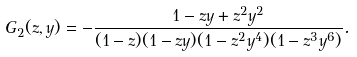Convert formula to latex. <formula><loc_0><loc_0><loc_500><loc_500>G _ { 2 } ( z , y ) = - \frac { 1 - z y + z ^ { 2 } y ^ { 2 } } { ( 1 - z ) ( 1 - z y ) ( 1 - z ^ { 2 } y ^ { 4 } ) ( 1 - z ^ { 3 } y ^ { 6 } ) } .</formula> 